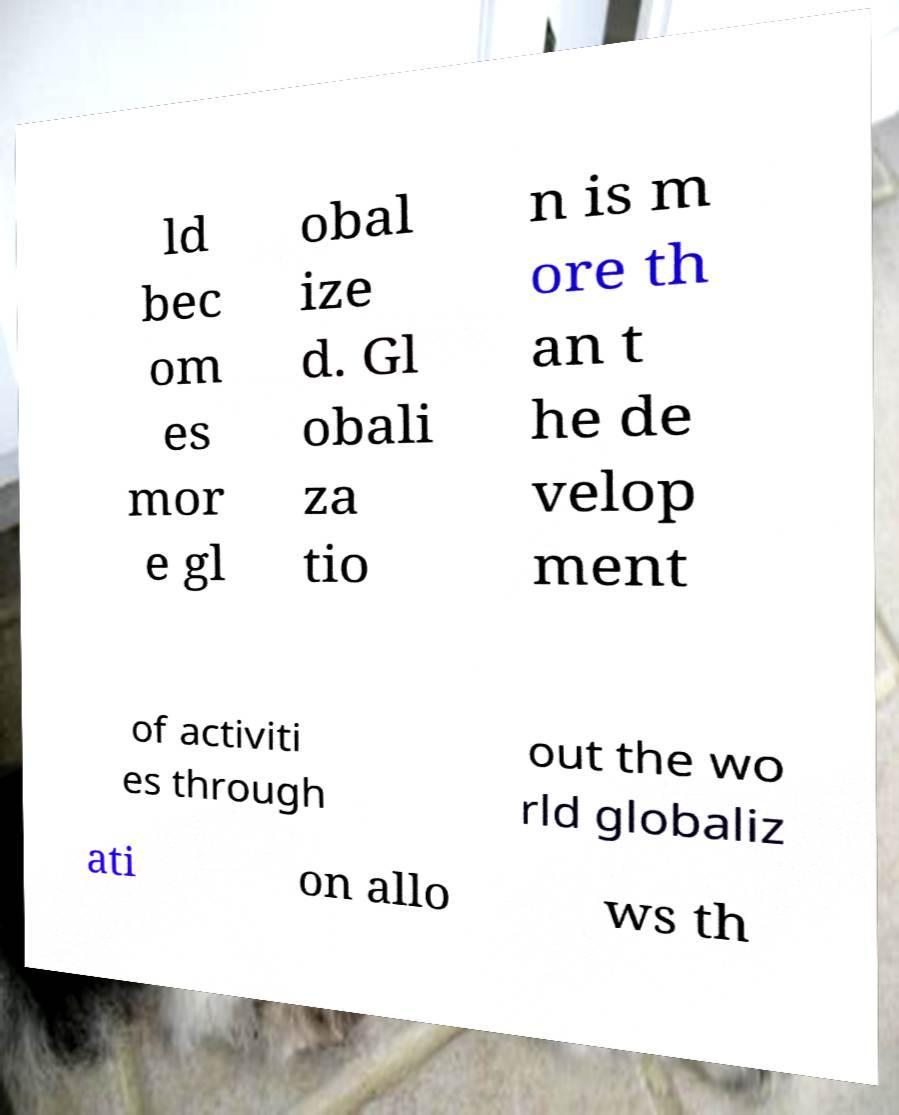Please read and relay the text visible in this image. What does it say? ld bec om es mor e gl obal ize d. Gl obali za tio n is m ore th an t he de velop ment of activiti es through out the wo rld globaliz ati on allo ws th 